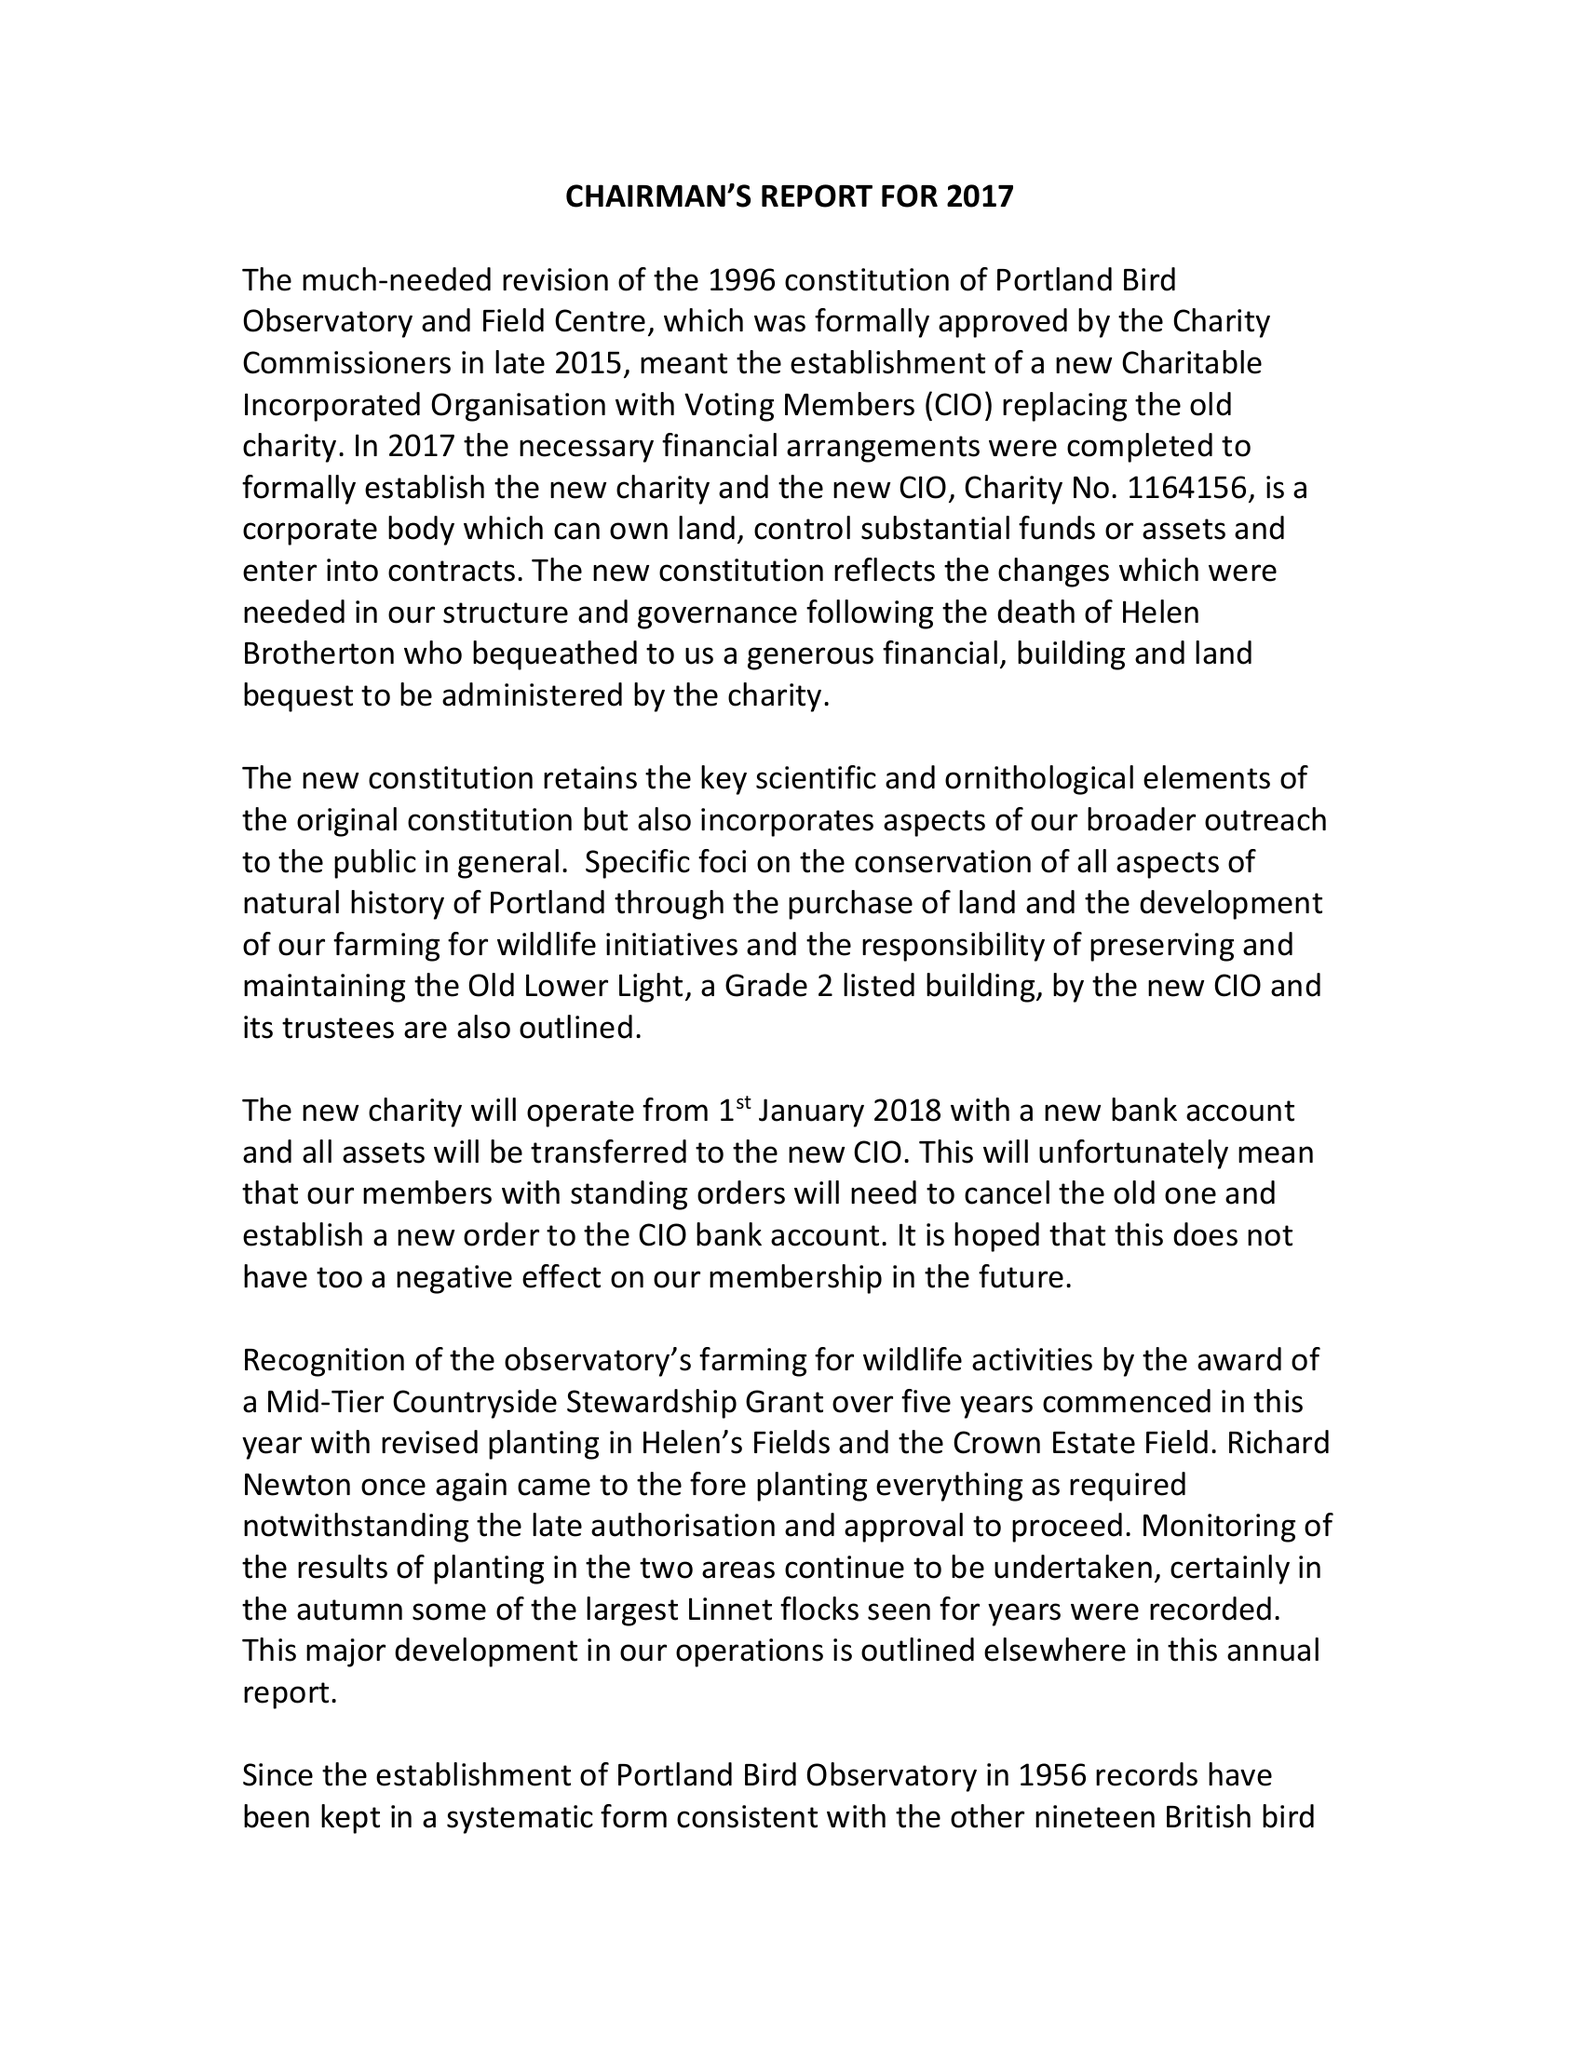What is the value for the charity_number?
Answer the question using a single word or phrase. 1164156 